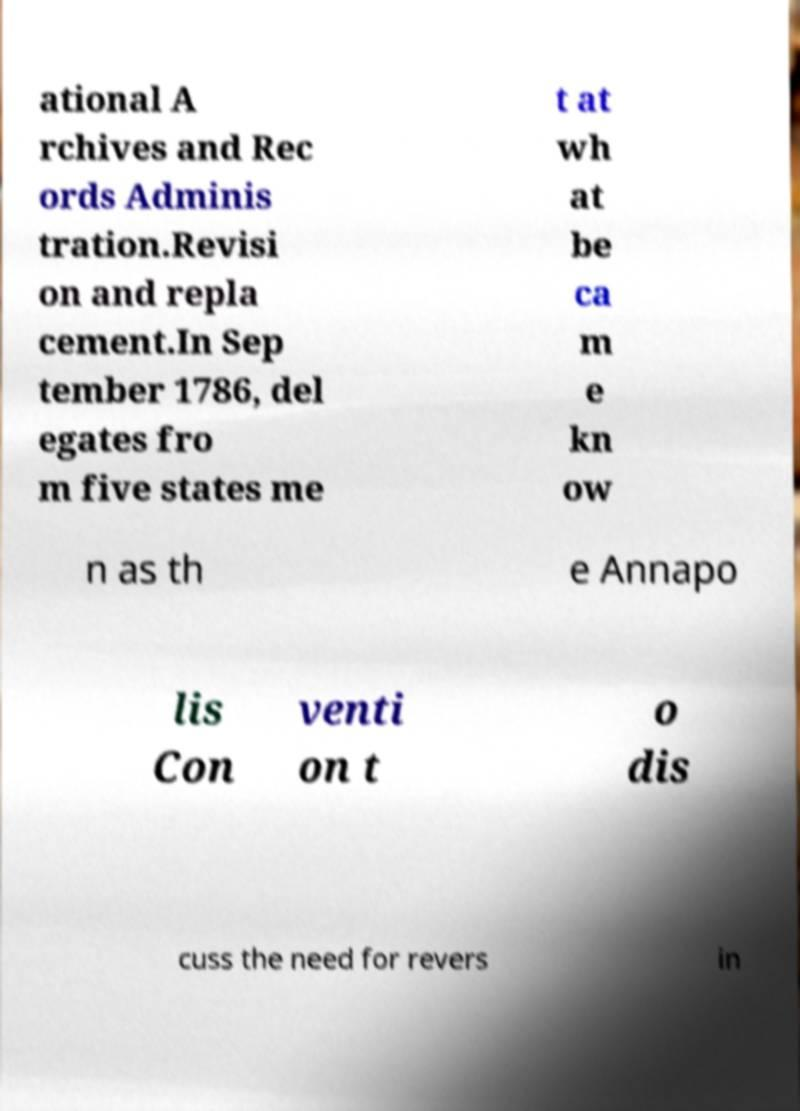I need the written content from this picture converted into text. Can you do that? ational A rchives and Rec ords Adminis tration.Revisi on and repla cement.In Sep tember 1786, del egates fro m five states me t at wh at be ca m e kn ow n as th e Annapo lis Con venti on t o dis cuss the need for revers in 